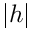Convert formula to latex. <formula><loc_0><loc_0><loc_500><loc_500>\left | h \right |</formula> 